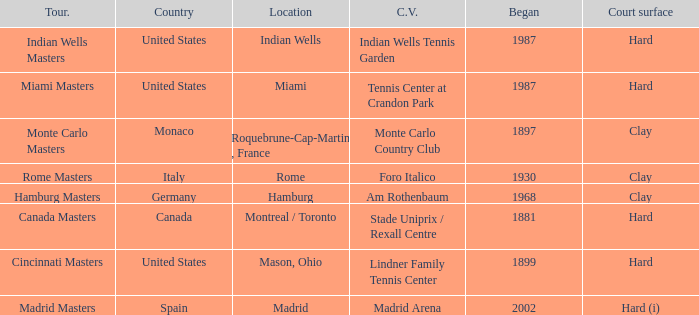Which tournaments current venue is the Madrid Arena? Madrid Masters. 